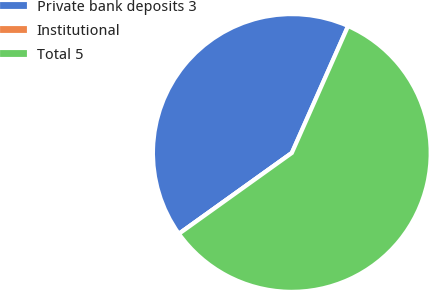Convert chart to OTSL. <chart><loc_0><loc_0><loc_500><loc_500><pie_chart><fcel>Private bank deposits 3<fcel>Institutional<fcel>Total 5<nl><fcel>41.53%<fcel>0.0%<fcel>58.47%<nl></chart> 